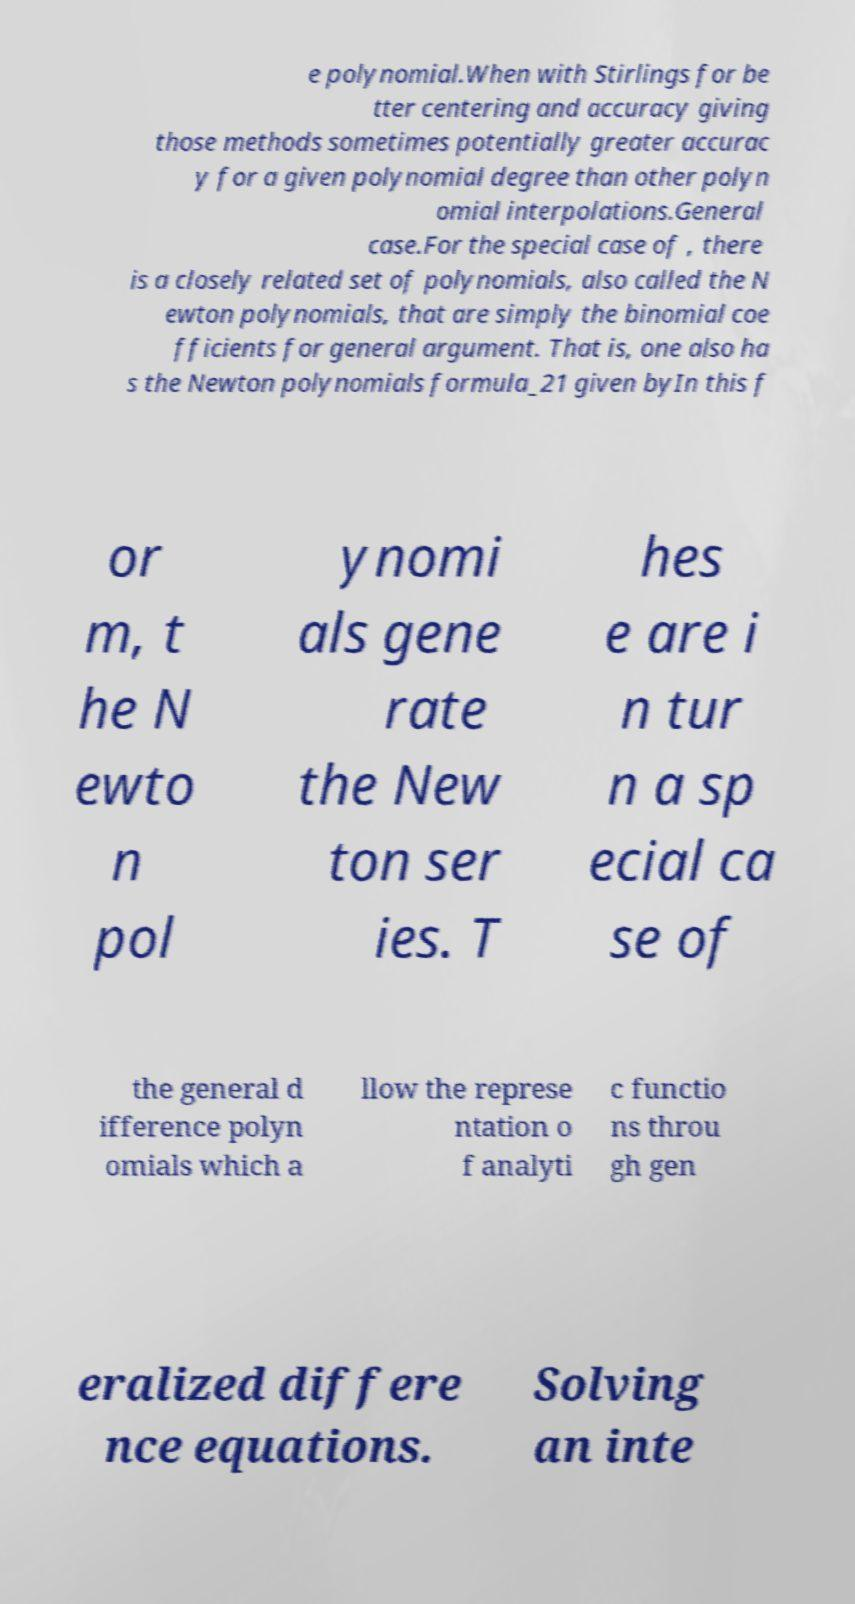Please identify and transcribe the text found in this image. e polynomial.When with Stirlings for be tter centering and accuracy giving those methods sometimes potentially greater accurac y for a given polynomial degree than other polyn omial interpolations.General case.For the special case of , there is a closely related set of polynomials, also called the N ewton polynomials, that are simply the binomial coe fficients for general argument. That is, one also ha s the Newton polynomials formula_21 given byIn this f or m, t he N ewto n pol ynomi als gene rate the New ton ser ies. T hes e are i n tur n a sp ecial ca se of the general d ifference polyn omials which a llow the represe ntation o f analyti c functio ns throu gh gen eralized differe nce equations. Solving an inte 